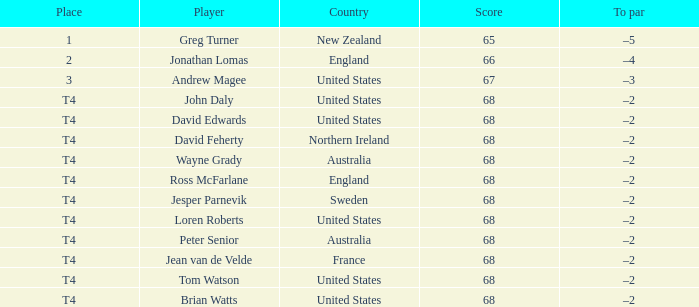Which To par has a Place of t4, and wayne grady is in? –2. 